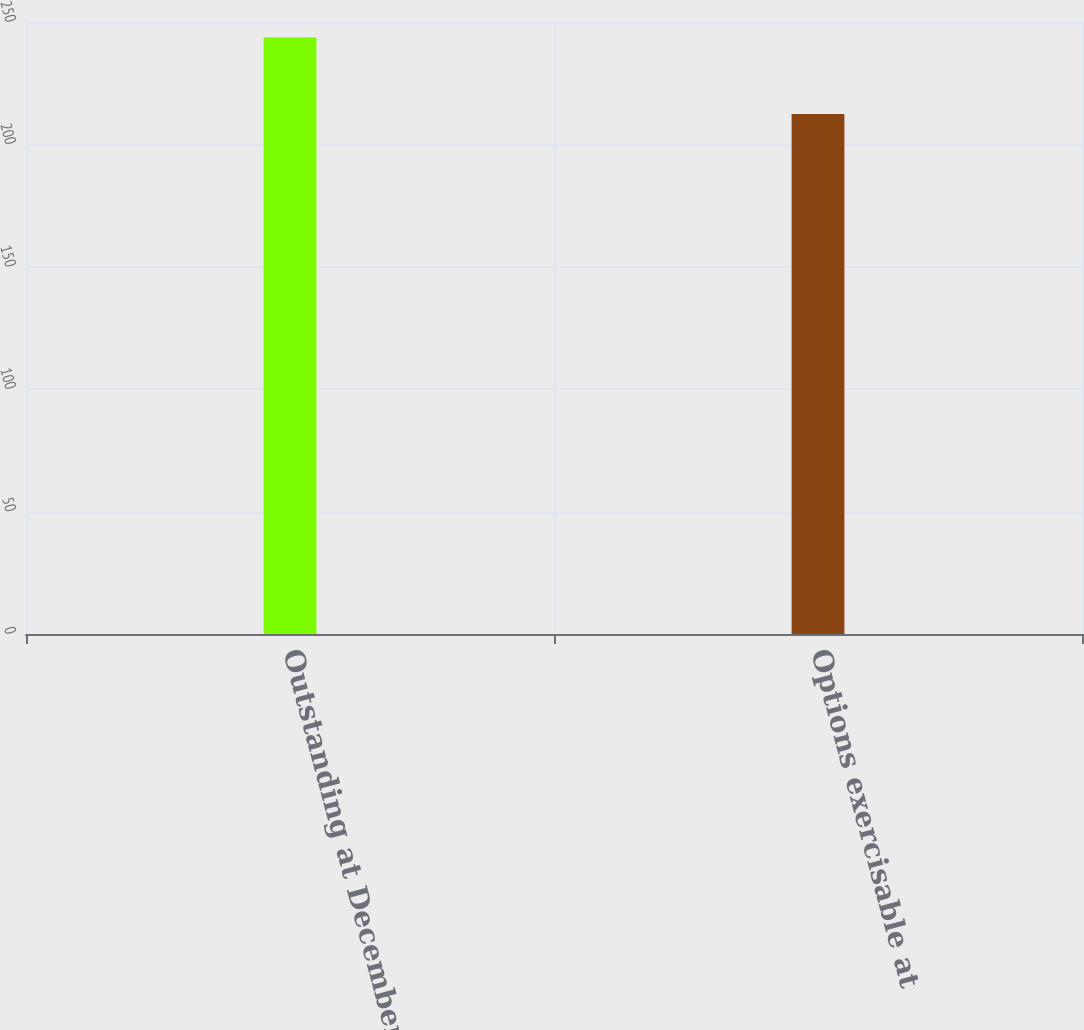Convert chart to OTSL. <chart><loc_0><loc_0><loc_500><loc_500><bar_chart><fcel>Outstanding at December 31<fcel>Options exercisable at<nl><fcel>243.7<fcel>212.38<nl></chart> 